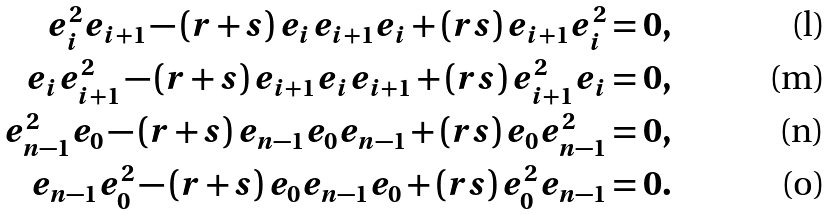Convert formula to latex. <formula><loc_0><loc_0><loc_500><loc_500>e _ { i } ^ { 2 } e _ { i + 1 } - ( r + s ) \, e _ { i } e _ { i + 1 } e _ { i } + ( r s ) \, e _ { i + 1 } e _ { i } ^ { 2 } = 0 , \\ e _ { i } e _ { i + 1 } ^ { 2 } - ( r + s ) \, e _ { i + 1 } e _ { i } e _ { i + 1 } + ( r s ) \, e _ { i + 1 } ^ { 2 } e _ { i } = 0 , \\ e _ { n - 1 } ^ { 2 } e _ { 0 } - ( r + s ) \, e _ { n - 1 } e _ { 0 } e _ { n - 1 } + ( r s ) \, e _ { 0 } e _ { n - 1 } ^ { 2 } = 0 , \\ e _ { n - 1 } e _ { 0 } ^ { 2 } - ( r + s ) \, e _ { 0 } e _ { n - 1 } e _ { 0 } + ( r s ) \, e _ { 0 } ^ { 2 } e _ { n - 1 } = 0 .</formula> 